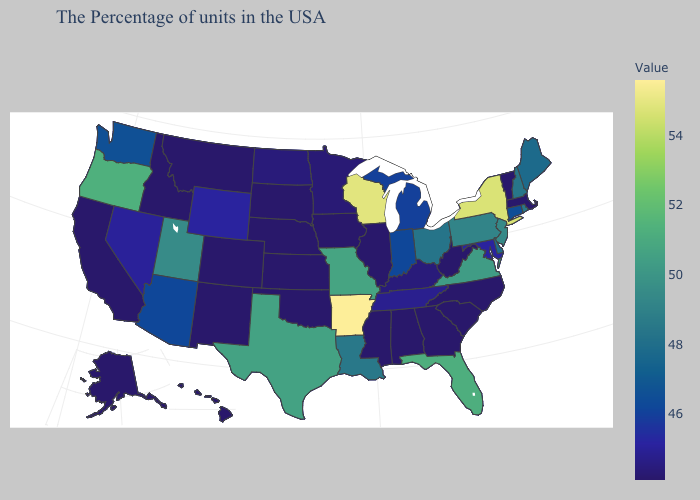Does Minnesota have the highest value in the MidWest?
Write a very short answer. No. Among the states that border New Mexico , which have the highest value?
Answer briefly. Texas. Which states have the lowest value in the South?
Answer briefly. North Carolina, South Carolina, West Virginia, Georgia, Alabama, Mississippi, Oklahoma. Among the states that border Nebraska , which have the highest value?
Short answer required. Missouri. 